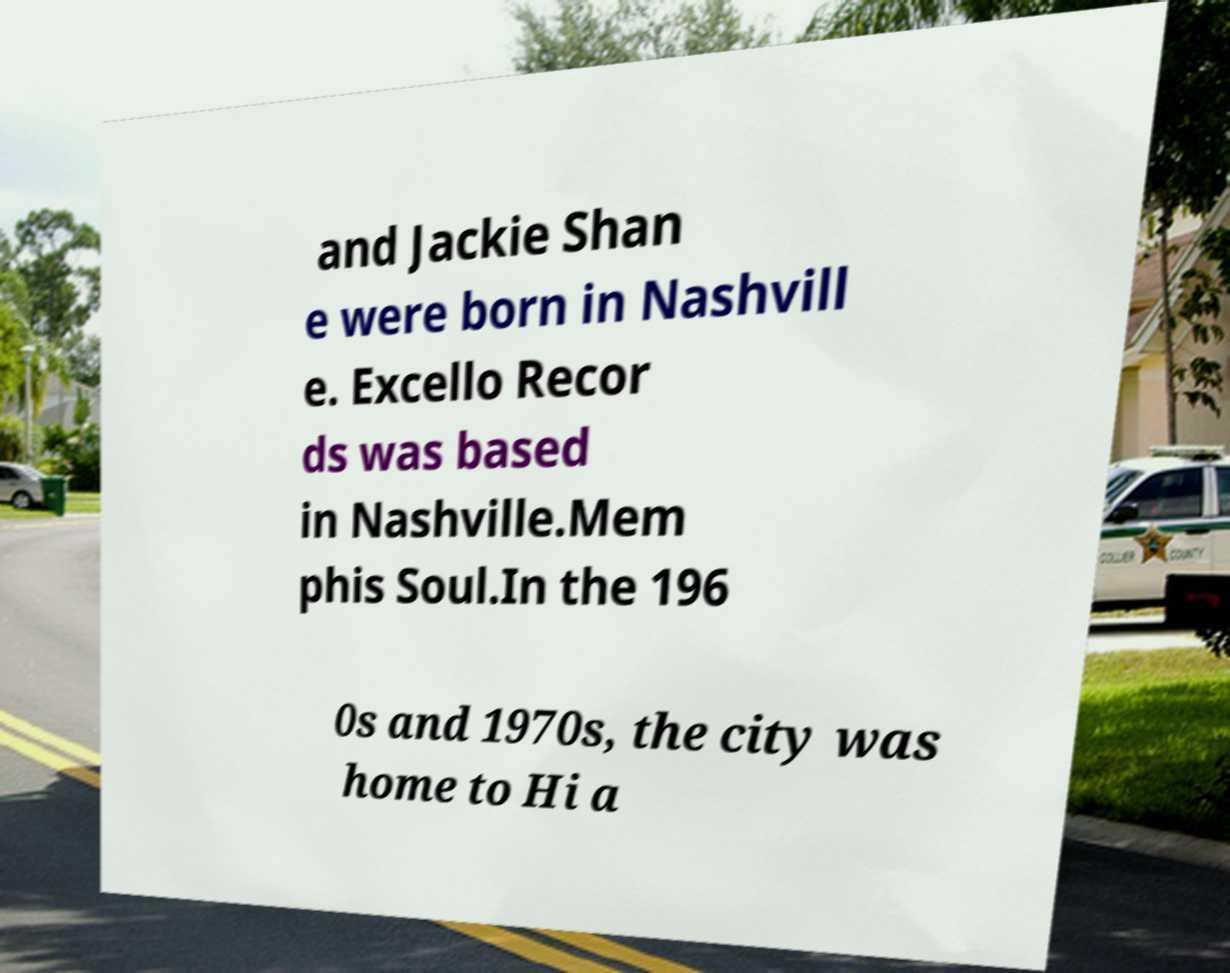Could you assist in decoding the text presented in this image and type it out clearly? and Jackie Shan e were born in Nashvill e. Excello Recor ds was based in Nashville.Mem phis Soul.In the 196 0s and 1970s, the city was home to Hi a 